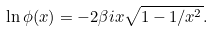<formula> <loc_0><loc_0><loc_500><loc_500>\ln \phi ( x ) = - 2 \beta i x \sqrt { 1 - 1 / x ^ { 2 } } .</formula> 